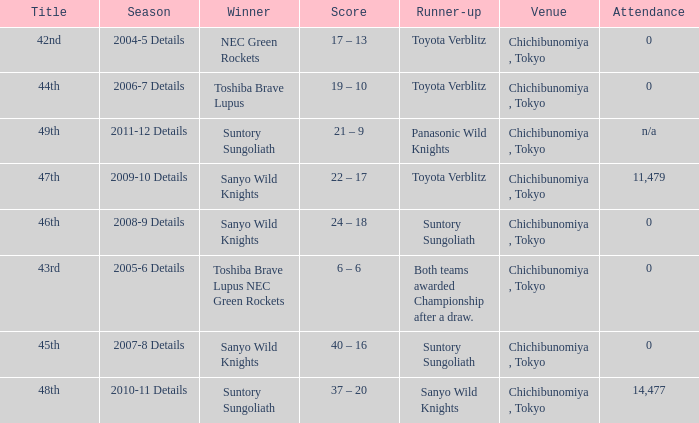What is the Title when the winner was suntory sungoliath, and a Season of 2011-12 details? 49th. 